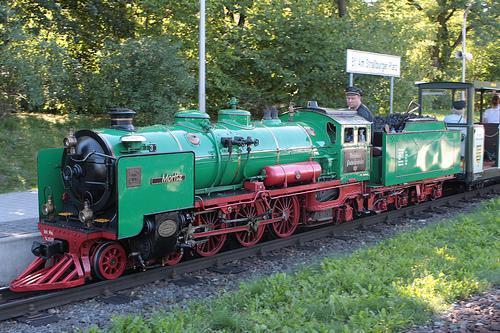How many people are there in the photo?
Give a very brief answer. 3. 